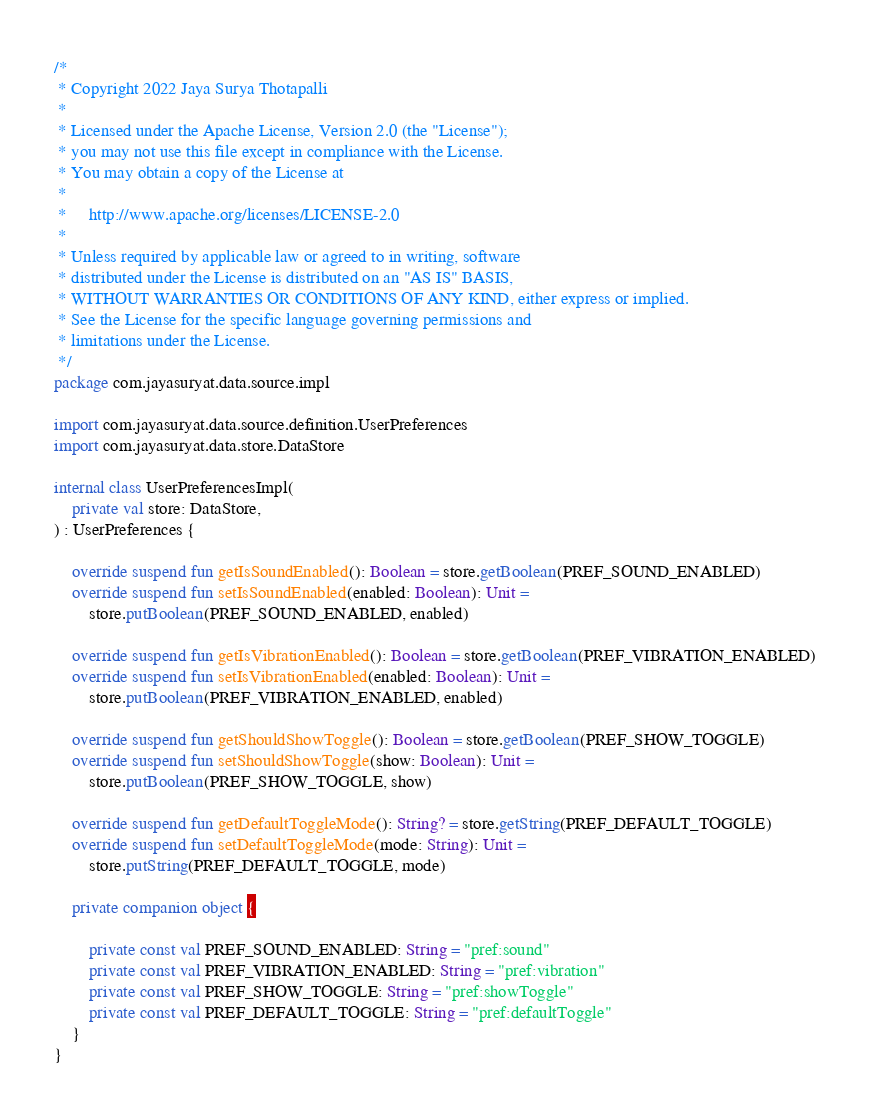<code> <loc_0><loc_0><loc_500><loc_500><_Kotlin_>/*
 * Copyright 2022 Jaya Surya Thotapalli
 *
 * Licensed under the Apache License, Version 2.0 (the "License");
 * you may not use this file except in compliance with the License.
 * You may obtain a copy of the License at
 *
 *     http://www.apache.org/licenses/LICENSE-2.0
 *
 * Unless required by applicable law or agreed to in writing, software
 * distributed under the License is distributed on an "AS IS" BASIS,
 * WITHOUT WARRANTIES OR CONDITIONS OF ANY KIND, either express or implied.
 * See the License for the specific language governing permissions and
 * limitations under the License.
 */
package com.jayasuryat.data.source.impl

import com.jayasuryat.data.source.definition.UserPreferences
import com.jayasuryat.data.store.DataStore

internal class UserPreferencesImpl(
    private val store: DataStore,
) : UserPreferences {

    override suspend fun getIsSoundEnabled(): Boolean = store.getBoolean(PREF_SOUND_ENABLED)
    override suspend fun setIsSoundEnabled(enabled: Boolean): Unit =
        store.putBoolean(PREF_SOUND_ENABLED, enabled)

    override suspend fun getIsVibrationEnabled(): Boolean = store.getBoolean(PREF_VIBRATION_ENABLED)
    override suspend fun setIsVibrationEnabled(enabled: Boolean): Unit =
        store.putBoolean(PREF_VIBRATION_ENABLED, enabled)

    override suspend fun getShouldShowToggle(): Boolean = store.getBoolean(PREF_SHOW_TOGGLE)
    override suspend fun setShouldShowToggle(show: Boolean): Unit =
        store.putBoolean(PREF_SHOW_TOGGLE, show)

    override suspend fun getDefaultToggleMode(): String? = store.getString(PREF_DEFAULT_TOGGLE)
    override suspend fun setDefaultToggleMode(mode: String): Unit =
        store.putString(PREF_DEFAULT_TOGGLE, mode)

    private companion object {

        private const val PREF_SOUND_ENABLED: String = "pref:sound"
        private const val PREF_VIBRATION_ENABLED: String = "pref:vibration"
        private const val PREF_SHOW_TOGGLE: String = "pref:showToggle"
        private const val PREF_DEFAULT_TOGGLE: String = "pref:defaultToggle"
    }
}
</code> 